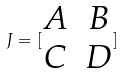<formula> <loc_0><loc_0><loc_500><loc_500>J = [ \begin{matrix} A & B \\ C & D \end{matrix} ]</formula> 